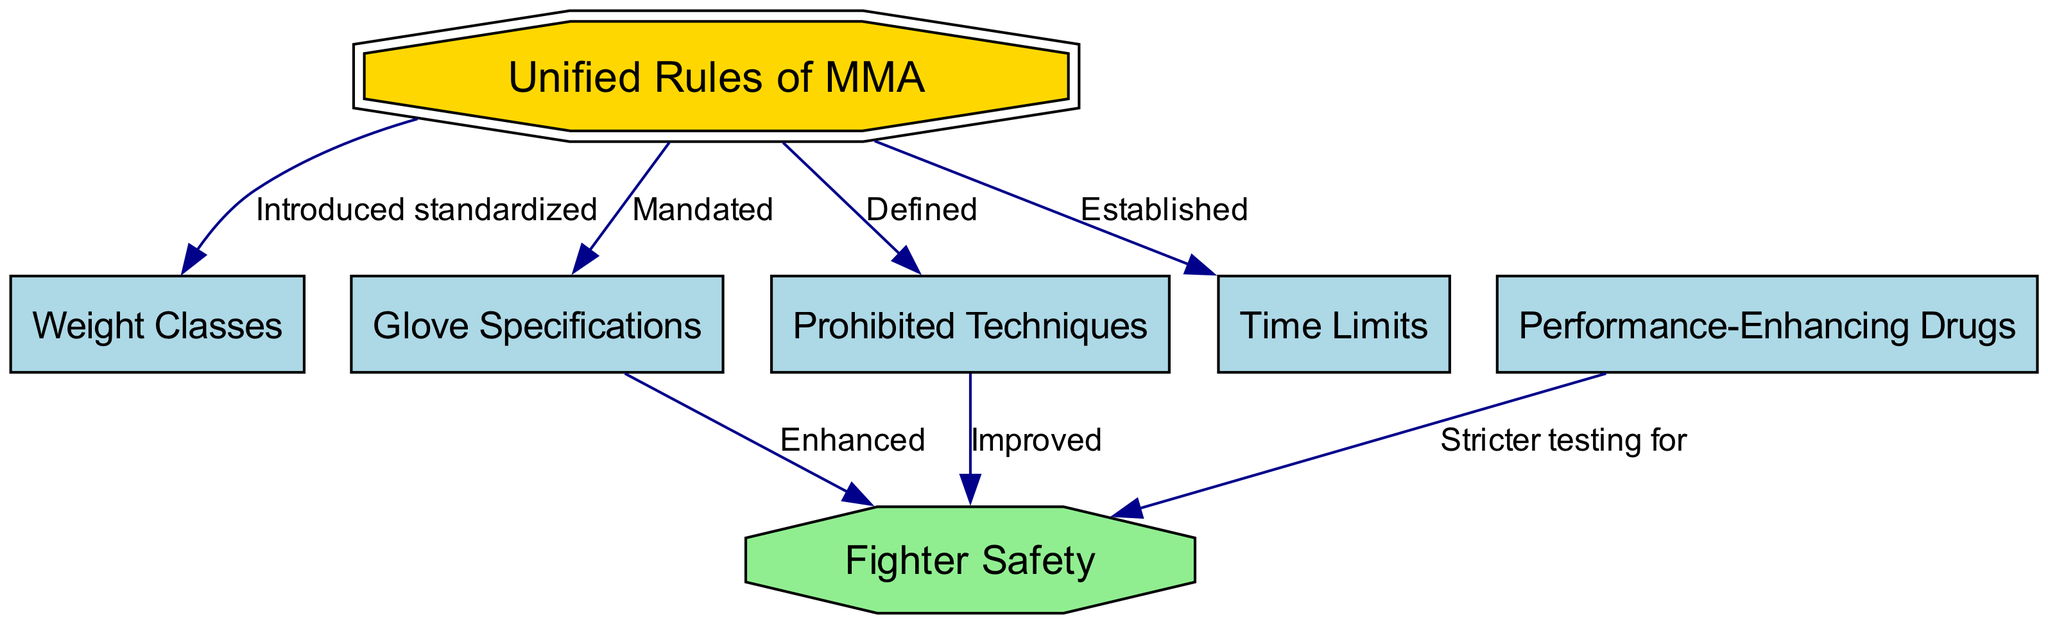What are the Unified Rules of MMA? The diagram shows that the Unified Rules of MMA are fundamental regulations in MMA competitions. They are indicated as the primary node from which several others branch off, signifying their importance.
Answer: Unified Rules of MMA How many nodes are in the diagram? By counting the nodes listed in the data, we can determine that there are a total of 7 nodes represented in the diagram.
Answer: 7 What technique is prohibited as defined by the Unified Rules of MMA? The diagram indicates that one of the branches from the Unified Rules of MMA is labeled "Defined," which corresponds to the node for Prohibited Techniques, indicating that these specific techniques are outlined within the Unified Rules.
Answer: Prohibited Techniques What is established in relation to Time Limits? The diagram shows that Time Limits are one of the nodes connected to Unified Rules of MMA, indicating that specific time constraints for bouts are established by these rules.
Answer: Established What led to improved Fighter Safety? The diagram shows that improved Fighter Safety has connections from both Prohibited Techniques and Glove Specifications. This indicates that these aspects contribute to the overall enhancement of safety for fighters.
Answer: Prohibited Techniques, Glove Specifications What does stricter testing impact in the diagram? The diagram connects stricter testing from Performance-Enhancing Drugs to Fighter Safety. This indicates that testing policies directly affect safety measures for fighters in the context of drug use.
Answer: Fighter Safety How are Glove Specifications related to Fighter Safety? The diagram indicates that Glove Specifications are linked to Fighter Safety, suggesting that these specifications enhance the safety of fighters by possibly reducing injury risk during competitions.
Answer: Enhanced What kind of changes did the Unified Rules of MMA introduce? The edges in the diagram show that the Unified Rules of MMA introduced standardized aspects such as weight classes, glove specifications, prohibited techniques, and time limits, highlighting their comprehensive regulation impact.
Answer: Standardized What are the relationships between Prohibited Techniques and Fighter Safety? The diagram clearly depicts a direct relationship where Prohibited Techniques contribute to improved Fighter Safety, suggesting an intrinsic link between the ban on certain techniques and the protection of fighters during bouts.
Answer: Improved 